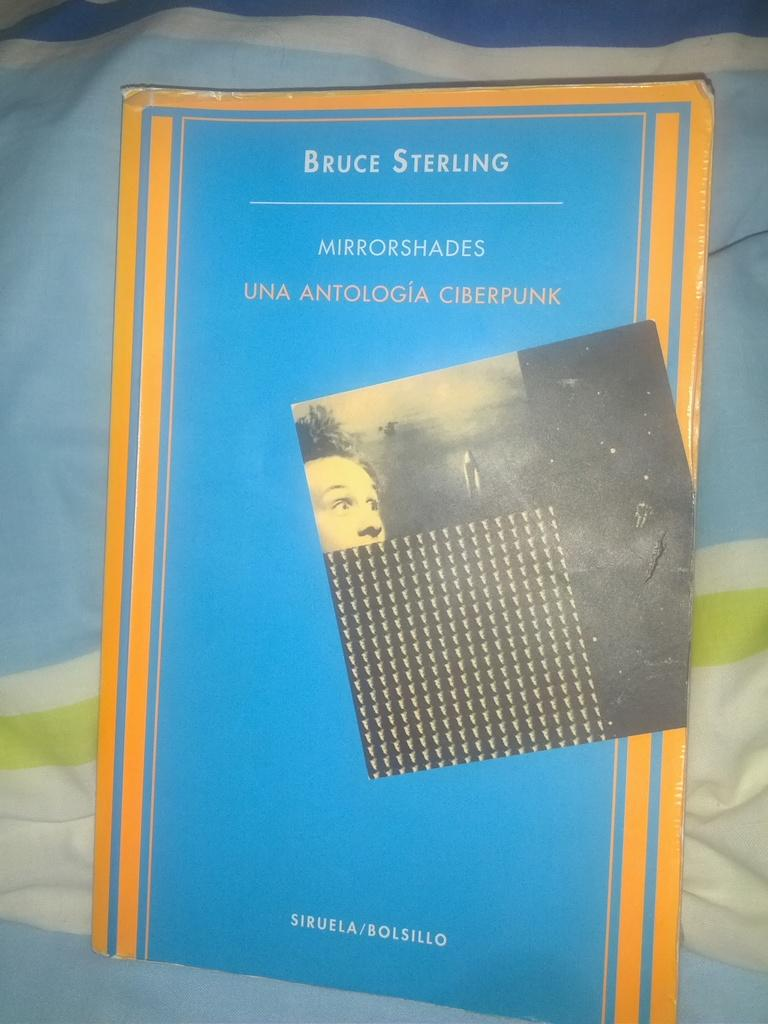<image>
Present a compact description of the photo's key features. The cover of the book Mirrorshades in blue with yellow trim. 